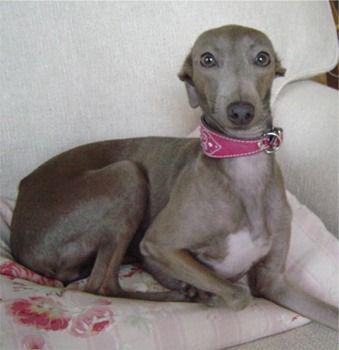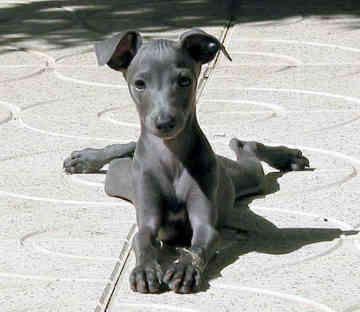The first image is the image on the left, the second image is the image on the right. For the images shown, is this caption "In both images the dogs are on the grass." true? Answer yes or no. No. 